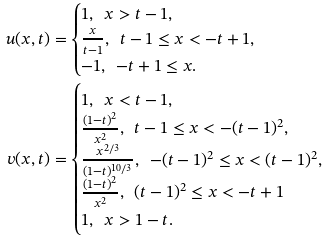<formula> <loc_0><loc_0><loc_500><loc_500>u ( x , t ) & = \begin{cases} 1 , \ \ x > t - 1 , \\ \frac { x } { t - 1 } , \ \ t - 1 \leq x < - t + 1 , \\ - 1 , \ \ - t + 1 \leq x . \end{cases} \\ v ( x , t ) & = \begin{cases} 1 , \ \ x < t - 1 , \\ \frac { ( 1 - t ) ^ { 2 } } { x ^ { 2 } } , \ \ t - 1 \leq x < - ( t - 1 ) ^ { 2 } , \\ \frac { x ^ { 2 / 3 } } { ( 1 - t ) ^ { 1 0 / 3 } } , \ \ - ( t - 1 ) ^ { 2 } \leq x < ( t - 1 ) ^ { 2 } , \\ \frac { ( 1 - t ) ^ { 2 } } { x ^ { 2 } } , \ \ ( t - 1 ) ^ { 2 } \leq x < - t + 1 \\ 1 , \ \ x > 1 - t . \end{cases}</formula> 